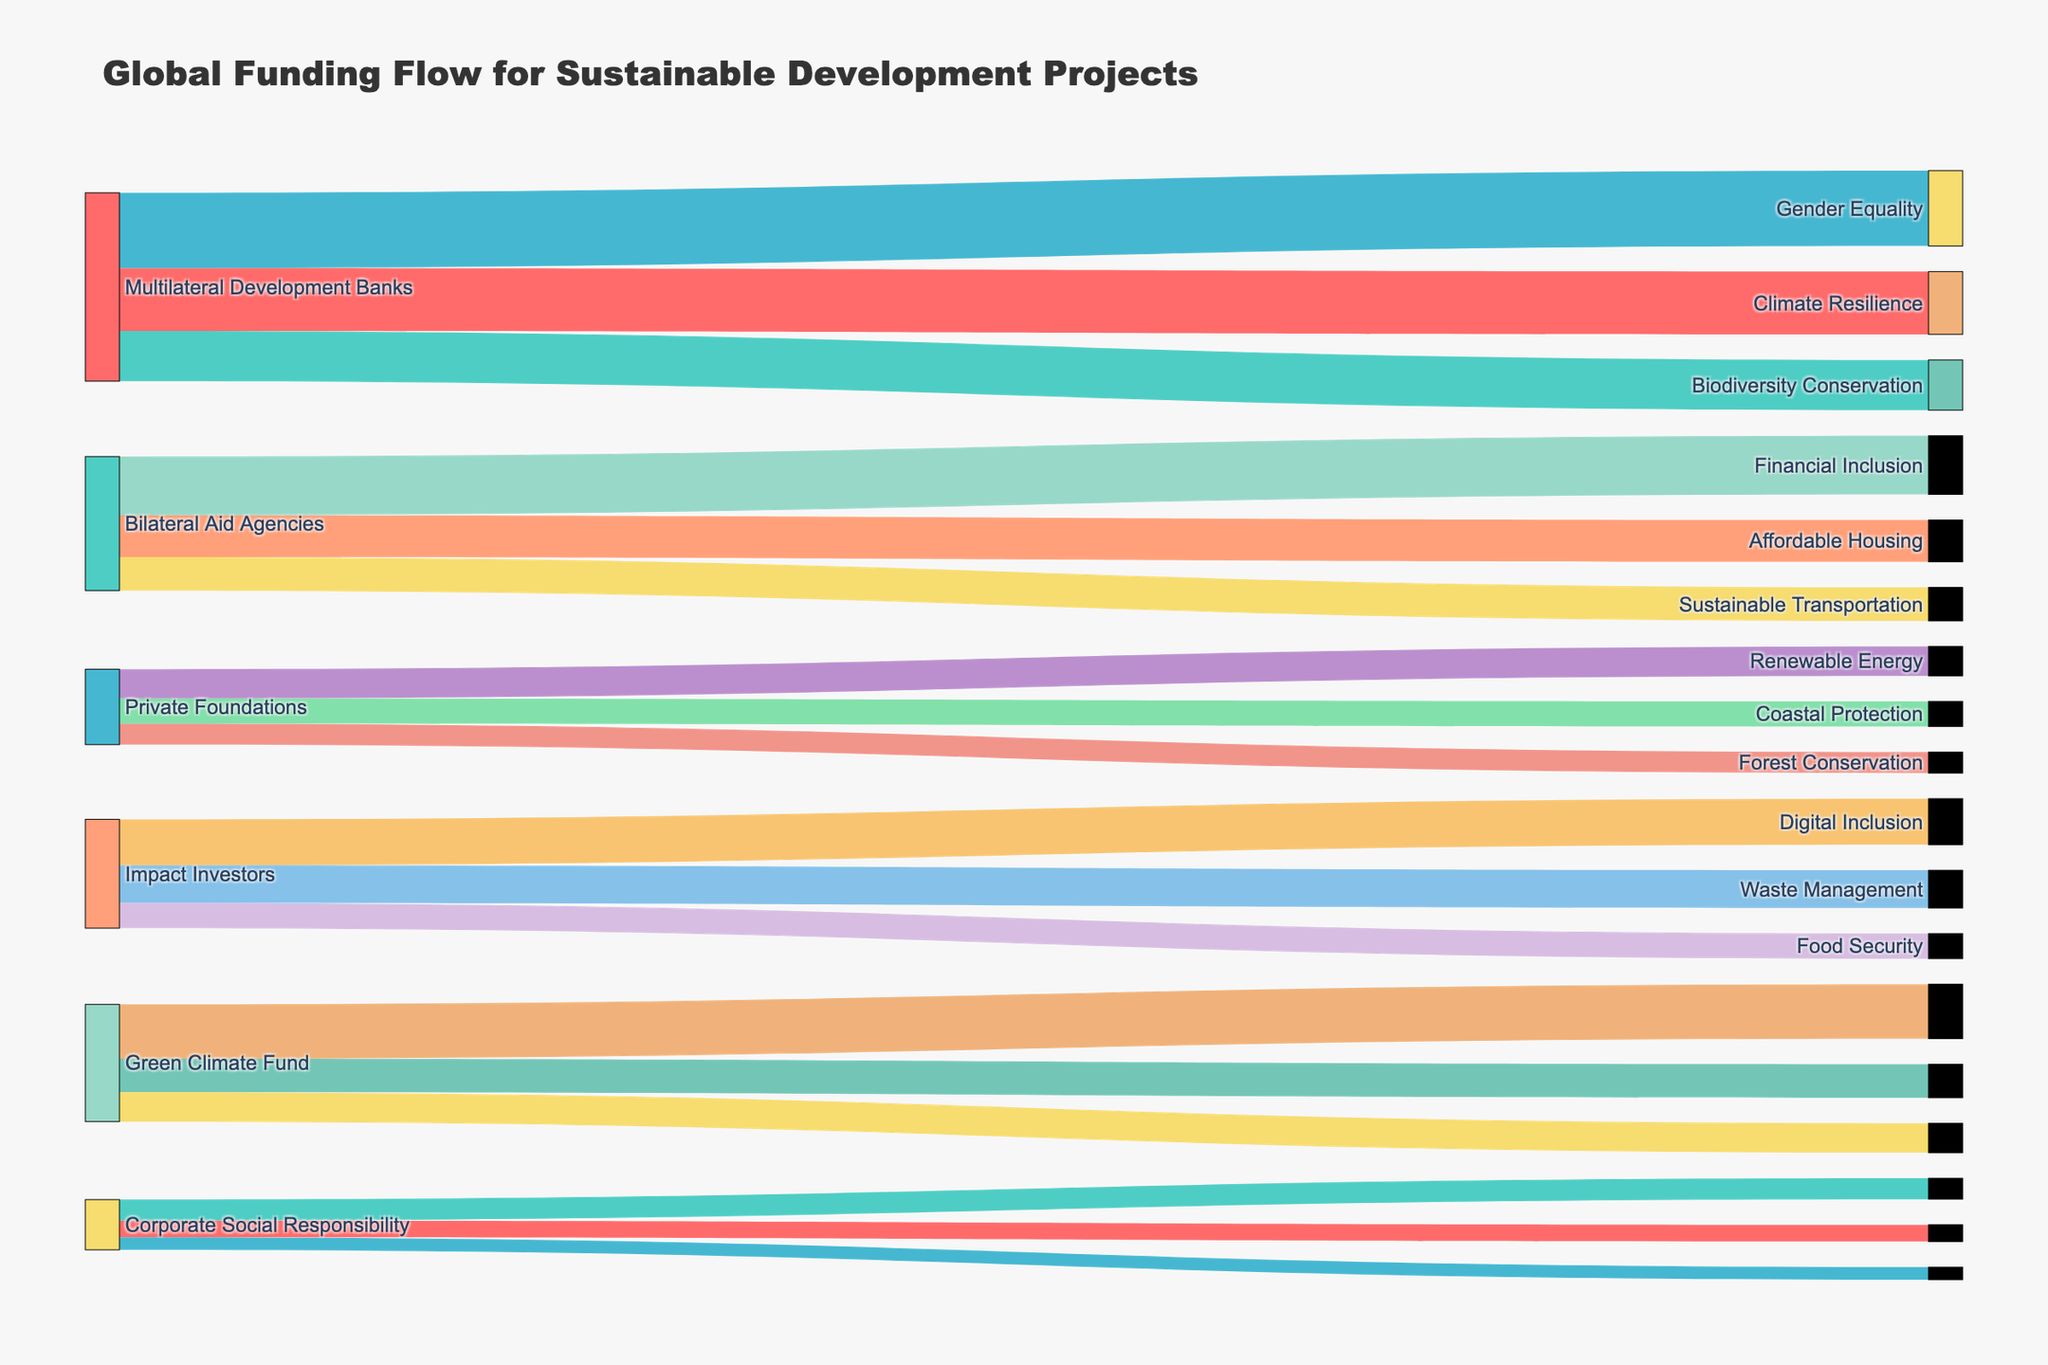What is the total amount of funding coming from Multilateral Development Banks? Identify and sum the values from Multilateral Development Banks to their respective sectors: 15 (Clean Energy) + 12 (Sustainable Agriculture) + 18 (Water and Sanitation) = 45.
Answer: 45 Which sector receives the highest amount of funding? Compare all the values across the sectors: the sector with the highest funding is Water and Sanitation with a value of 18.
Answer: Water and Sanitation How much funding is directed towards Climate Resilience from Private Foundations? Locate the specific funding connection from Private Foundations to Climate Resilience in the Sankey Diagram, which is 7.
Answer: 7 Which funding source contributes the most to Sustainable Transportation? Identify the source providing funding to Sustainable Transportation. Impact Investors allocate 6 to Sustainable Transportation.
Answer: Impact Investors What is the combined total funding for Healthcare and Education from Bilateral Aid Agencies? Sum the values allocated by Bilateral Aid Agencies to Healthcare and Education: 14 (Healthcare) + 10 (Education) = 24.
Answer: 24 Among Corporate Social Responsibility, what sector receives the least funding? Identify and compare the values directed by Corporate Social Responsibility to various sectors: Waste Management (4), Digital Inclusion (5), Food Security (3). The least is 3 (Food Security).
Answer: Food Security How does funding for Forest Conservation from Green Climate Fund compare to funding for Coastal Protection from the same source? Compare the values allocated by the Green Climate Fund: Forest Conservation (8) versus Coastal Protection (7). Thus, Forest Conservation receives slightly more funding.
Answer: Forest Conservation What is the total value of funding allocated to Sustainable Development sectors by Impact Investors? Sum the funding values from Impact Investors to their respective sectors: 9 (Affordable Housing) + 11 (Financial Inclusion) + 6 (Sustainable Transportation) = 26.
Answer: 26 Which two sectors receive funding from the highest number of unique sources? Count the number of unique sources for each sector: Clean Energy (1), Sustainable Agriculture (1), Water and Sanitation (1), Education (1), Healthcare (1), Sustainable Cities (1), Climate Resilience (1), Biodiversity Conservation (1), Gender Equality (1), Affordable Housing (1), Financial Inclusion (1), Sustainable Transportation (1), Renewable Energy (1), Forest Conservation (1), Coastal Protection (1), Waste Management (1), Digital Inclusion (1), Food Security (1). All sectors are funded by only one unique source.
Answer: All sectors are evenly funded by one unique source What is the average funding directed towards sectors supported by Private Foundations? Sum the funding values from Private Foundations to their respective sectors and then divide by the number of sectors: (7 + 5 + 6) / 3 = 6.
Answer: 6 